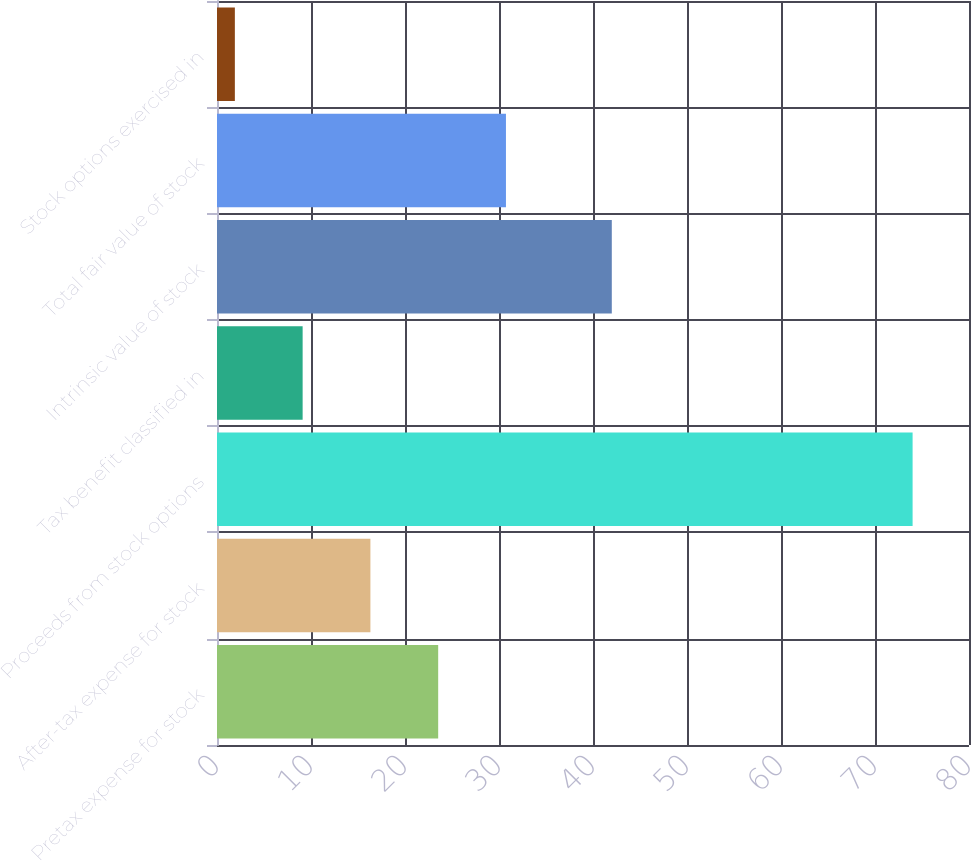Convert chart to OTSL. <chart><loc_0><loc_0><loc_500><loc_500><bar_chart><fcel>Pretax expense for stock<fcel>After-tax expense for stock<fcel>Proceeds from stock options<fcel>Tax benefit classified in<fcel>Intrinsic value of stock<fcel>Total fair value of stock<fcel>Stock options exercised in<nl><fcel>23.53<fcel>16.32<fcel>74<fcel>9.11<fcel>42<fcel>30.74<fcel>1.9<nl></chart> 